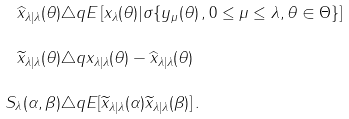Convert formula to latex. <formula><loc_0><loc_0><loc_500><loc_500>\widehat { x } _ { \lambda | \lambda } ( \theta ) & \triangle q E \left [ x _ { \lambda } ( \theta ) | \sigma \{ y _ { \mu } ( \theta ) \, , 0 \leq \mu \leq \lambda , \theta \in \Theta \} \right ] \\ \widetilde { x } _ { \lambda | \lambda } ( \theta ) & \triangle q { x } _ { \lambda | \lambda } ( \theta ) - \widehat { x } _ { \lambda | \lambda } ( \theta ) \\ S _ { \lambda } ( \alpha , \beta ) & \triangle q E [ \widetilde { x } _ { \lambda | \lambda } ( \alpha ) \widetilde { x } _ { \lambda | \lambda } ( \beta ) ] \, .</formula> 